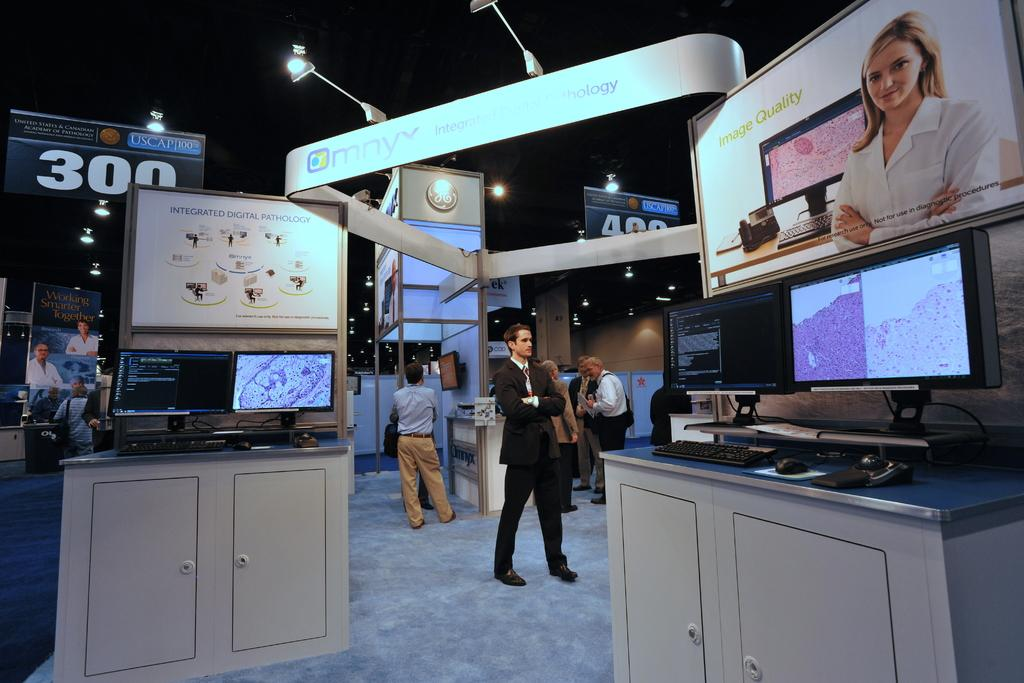<image>
Render a clear and concise summary of the photo. A banner hanging that says United States & Canadian Academy of Pathology. 